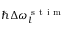Convert formula to latex. <formula><loc_0><loc_0><loc_500><loc_500>\hbar { \Delta } \omega _ { l } ^ { s t i m }</formula> 